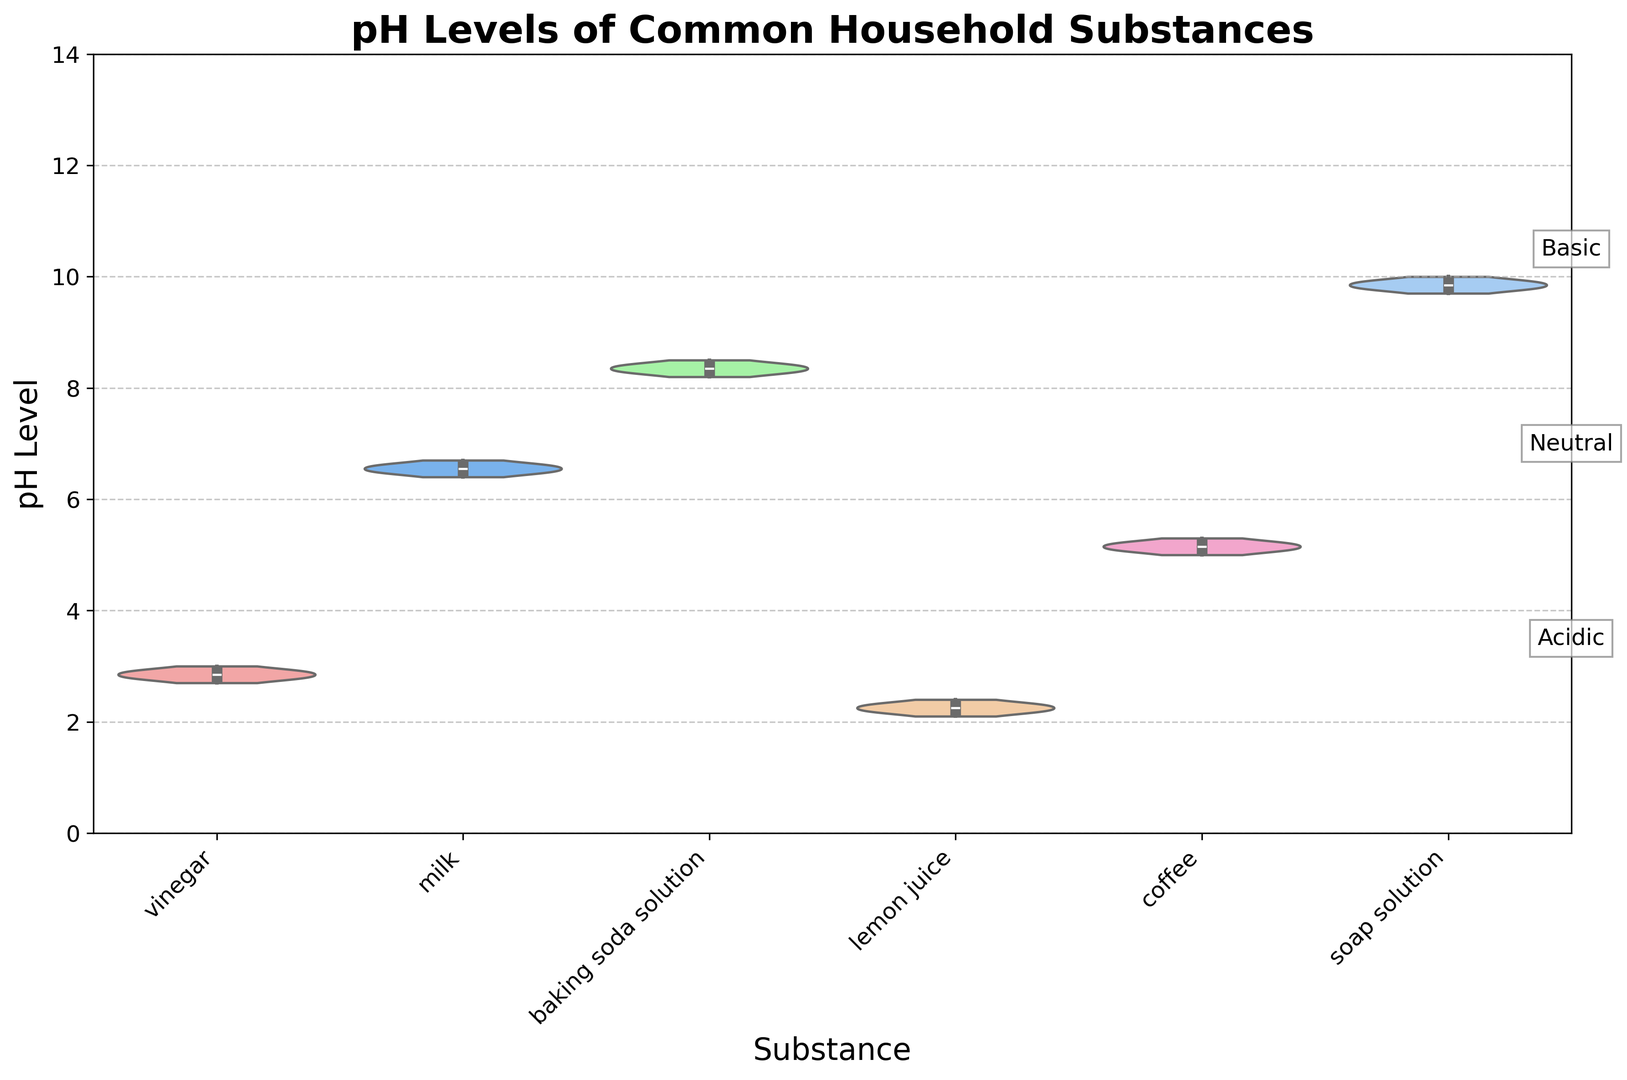What is the median pH level of vinegar across all brands? To find the median, look at the middle value when pH levels are sorted. For vinegar, pH levels are 2.7, 2.8, 2.8, 2.8, 2.9, 2.9, 2.9, and 3.0. The median is the average of the 4th and 5th values (2.8 and 2.9).
Answer: 2.85 Which substance has the widest distribution of pH values? The substance with the widest distribution will have the broadest violin plot. Observing the plot, the soap solution has the widest range from approximately 9.7 to 10.0.
Answer: Soap solution Are there any substances with pH ranges that do not overlap with any other substance's pH range? By examining the extents and overlaps of the violins, vinegar (approx. 2.7-3.0) and lemon juice (approx. 2.1-2.4) have overlapping pH ranges. The unique range to look for is soap solution, which ranges from approx. 9.7-10.0, not overlapping with others.
Answer: Yes, soap solution Which brand's pH meter shows the lowest pH value for coffee? Check the data points for coffee. The lowest pH shown is 5.0 by Horiba for coffee.
Answer: Horiba What is the average pH level of milk? List the pH values for milk: 6.5, 6.6, 6.4, 6.7, 6.6, 6.5, 6.5, 6.6. Sum these values and divide by the number of data points. Sum = 52.4, number of measurements = 8, so average is 52.4/8.
Answer: 6.55 Of the substances shown, which appear to be acidic based on the pH scale reference in the plot? Acidic substances will have pH values less than 7. The plot shows vinegar, lemon juice, and coffee having pH values in the acidic range.
Answer: Vinegar, lemon juice, coffee Is there a clear trend in pH values among different brands for any substance? To identify trends, look for consistent positioning within each substance's violin distribution. For example, all brands show close pH values for milk and baking soda solution, indicating consistency.
Answer: Yes, for milk and baking soda solution Which substance shows the least variability in pH values? The substance with the most compressed violin plot has the least variability. Baking soda solution shows the narrowest distribution from around 8.2 to 8.5.
Answer: Baking soda solution 